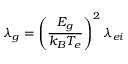Convert formula to latex. <formula><loc_0><loc_0><loc_500><loc_500>\lambda _ { g } = \left ( \frac { E _ { g } } { k _ { B } T _ { e } } \right ) ^ { 2 } \lambda _ { e i }</formula> 